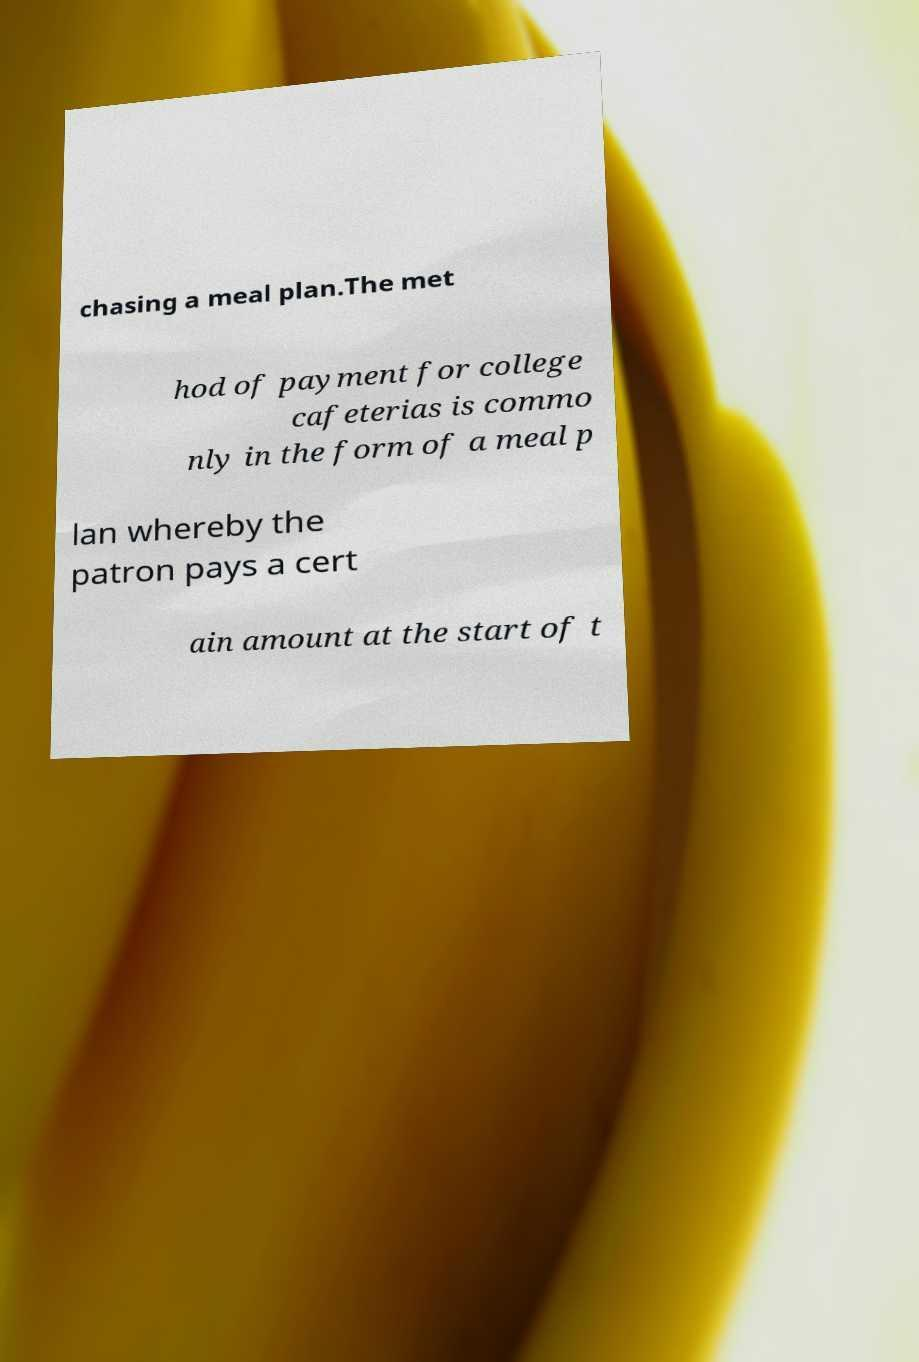Please read and relay the text visible in this image. What does it say? chasing a meal plan.The met hod of payment for college cafeterias is commo nly in the form of a meal p lan whereby the patron pays a cert ain amount at the start of t 